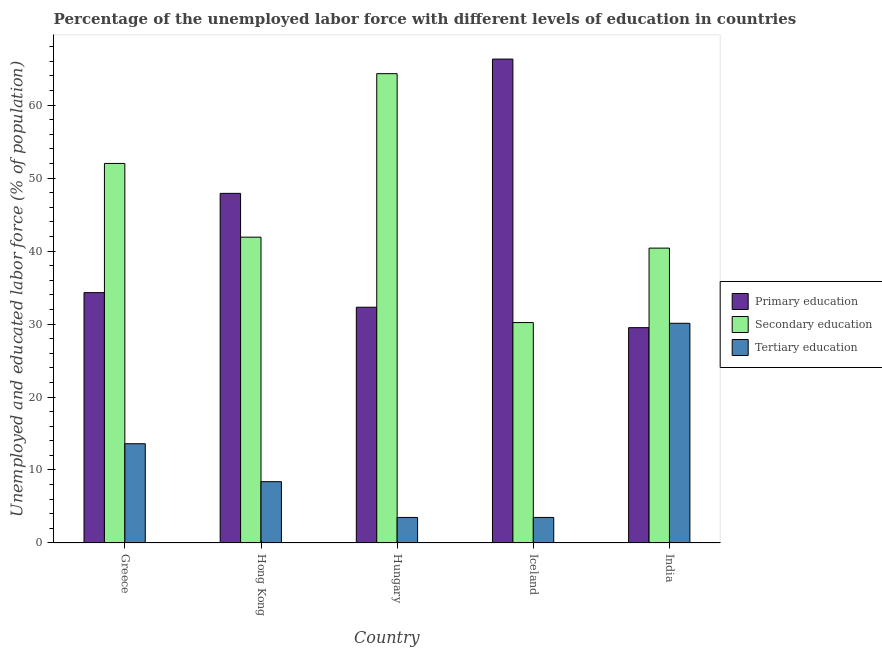How many bars are there on the 1st tick from the right?
Your answer should be compact. 3. What is the label of the 2nd group of bars from the left?
Provide a short and direct response. Hong Kong. What is the percentage of labor force who received primary education in India?
Provide a short and direct response. 29.5. Across all countries, what is the maximum percentage of labor force who received secondary education?
Your answer should be very brief. 64.3. Across all countries, what is the minimum percentage of labor force who received primary education?
Offer a very short reply. 29.5. In which country was the percentage of labor force who received tertiary education maximum?
Your answer should be compact. India. In which country was the percentage of labor force who received secondary education minimum?
Your answer should be very brief. Iceland. What is the total percentage of labor force who received primary education in the graph?
Make the answer very short. 210.3. What is the difference between the percentage of labor force who received tertiary education in Hong Kong and that in Hungary?
Ensure brevity in your answer.  4.9. What is the difference between the percentage of labor force who received secondary education in Iceland and the percentage of labor force who received primary education in India?
Keep it short and to the point. 0.7. What is the average percentage of labor force who received secondary education per country?
Provide a short and direct response. 45.76. What is the difference between the percentage of labor force who received secondary education and percentage of labor force who received primary education in India?
Your answer should be compact. 10.9. In how many countries, is the percentage of labor force who received tertiary education greater than 10 %?
Ensure brevity in your answer.  2. What is the ratio of the percentage of labor force who received secondary education in Greece to that in India?
Your answer should be very brief. 1.29. What is the difference between the highest and the second highest percentage of labor force who received secondary education?
Ensure brevity in your answer.  12.3. What is the difference between the highest and the lowest percentage of labor force who received secondary education?
Offer a very short reply. 34.1. Is the sum of the percentage of labor force who received secondary education in Hungary and Iceland greater than the maximum percentage of labor force who received tertiary education across all countries?
Your response must be concise. Yes. What does the 3rd bar from the left in Hungary represents?
Your answer should be compact. Tertiary education. What does the 2nd bar from the right in Hungary represents?
Ensure brevity in your answer.  Secondary education. What is the difference between two consecutive major ticks on the Y-axis?
Provide a short and direct response. 10. Does the graph contain any zero values?
Your response must be concise. No. Where does the legend appear in the graph?
Provide a succinct answer. Center right. What is the title of the graph?
Ensure brevity in your answer.  Percentage of the unemployed labor force with different levels of education in countries. Does "Male employers" appear as one of the legend labels in the graph?
Make the answer very short. No. What is the label or title of the Y-axis?
Give a very brief answer. Unemployed and educated labor force (% of population). What is the Unemployed and educated labor force (% of population) of Primary education in Greece?
Your response must be concise. 34.3. What is the Unemployed and educated labor force (% of population) in Secondary education in Greece?
Your answer should be compact. 52. What is the Unemployed and educated labor force (% of population) in Tertiary education in Greece?
Make the answer very short. 13.6. What is the Unemployed and educated labor force (% of population) of Primary education in Hong Kong?
Your answer should be very brief. 47.9. What is the Unemployed and educated labor force (% of population) in Secondary education in Hong Kong?
Give a very brief answer. 41.9. What is the Unemployed and educated labor force (% of population) of Tertiary education in Hong Kong?
Your response must be concise. 8.4. What is the Unemployed and educated labor force (% of population) in Primary education in Hungary?
Make the answer very short. 32.3. What is the Unemployed and educated labor force (% of population) in Secondary education in Hungary?
Your answer should be very brief. 64.3. What is the Unemployed and educated labor force (% of population) of Tertiary education in Hungary?
Make the answer very short. 3.5. What is the Unemployed and educated labor force (% of population) in Primary education in Iceland?
Offer a terse response. 66.3. What is the Unemployed and educated labor force (% of population) in Secondary education in Iceland?
Your answer should be compact. 30.2. What is the Unemployed and educated labor force (% of population) in Primary education in India?
Offer a terse response. 29.5. What is the Unemployed and educated labor force (% of population) in Secondary education in India?
Your answer should be very brief. 40.4. What is the Unemployed and educated labor force (% of population) in Tertiary education in India?
Your answer should be compact. 30.1. Across all countries, what is the maximum Unemployed and educated labor force (% of population) of Primary education?
Offer a very short reply. 66.3. Across all countries, what is the maximum Unemployed and educated labor force (% of population) in Secondary education?
Offer a very short reply. 64.3. Across all countries, what is the maximum Unemployed and educated labor force (% of population) of Tertiary education?
Give a very brief answer. 30.1. Across all countries, what is the minimum Unemployed and educated labor force (% of population) of Primary education?
Keep it short and to the point. 29.5. Across all countries, what is the minimum Unemployed and educated labor force (% of population) in Secondary education?
Keep it short and to the point. 30.2. Across all countries, what is the minimum Unemployed and educated labor force (% of population) in Tertiary education?
Your answer should be compact. 3.5. What is the total Unemployed and educated labor force (% of population) of Primary education in the graph?
Ensure brevity in your answer.  210.3. What is the total Unemployed and educated labor force (% of population) of Secondary education in the graph?
Ensure brevity in your answer.  228.8. What is the total Unemployed and educated labor force (% of population) of Tertiary education in the graph?
Your answer should be very brief. 59.1. What is the difference between the Unemployed and educated labor force (% of population) in Primary education in Greece and that in Hong Kong?
Make the answer very short. -13.6. What is the difference between the Unemployed and educated labor force (% of population) in Tertiary education in Greece and that in Hong Kong?
Your response must be concise. 5.2. What is the difference between the Unemployed and educated labor force (% of population) in Primary education in Greece and that in Hungary?
Provide a short and direct response. 2. What is the difference between the Unemployed and educated labor force (% of population) of Primary education in Greece and that in Iceland?
Provide a succinct answer. -32. What is the difference between the Unemployed and educated labor force (% of population) in Secondary education in Greece and that in Iceland?
Ensure brevity in your answer.  21.8. What is the difference between the Unemployed and educated labor force (% of population) of Tertiary education in Greece and that in Iceland?
Keep it short and to the point. 10.1. What is the difference between the Unemployed and educated labor force (% of population) of Primary education in Greece and that in India?
Offer a very short reply. 4.8. What is the difference between the Unemployed and educated labor force (% of population) of Secondary education in Greece and that in India?
Provide a short and direct response. 11.6. What is the difference between the Unemployed and educated labor force (% of population) of Tertiary education in Greece and that in India?
Provide a short and direct response. -16.5. What is the difference between the Unemployed and educated labor force (% of population) in Secondary education in Hong Kong and that in Hungary?
Your answer should be compact. -22.4. What is the difference between the Unemployed and educated labor force (% of population) of Primary education in Hong Kong and that in Iceland?
Keep it short and to the point. -18.4. What is the difference between the Unemployed and educated labor force (% of population) of Secondary education in Hong Kong and that in India?
Your answer should be compact. 1.5. What is the difference between the Unemployed and educated labor force (% of population) of Tertiary education in Hong Kong and that in India?
Make the answer very short. -21.7. What is the difference between the Unemployed and educated labor force (% of population) of Primary education in Hungary and that in Iceland?
Provide a short and direct response. -34. What is the difference between the Unemployed and educated labor force (% of population) of Secondary education in Hungary and that in Iceland?
Offer a terse response. 34.1. What is the difference between the Unemployed and educated labor force (% of population) in Tertiary education in Hungary and that in Iceland?
Keep it short and to the point. 0. What is the difference between the Unemployed and educated labor force (% of population) of Secondary education in Hungary and that in India?
Ensure brevity in your answer.  23.9. What is the difference between the Unemployed and educated labor force (% of population) of Tertiary education in Hungary and that in India?
Your response must be concise. -26.6. What is the difference between the Unemployed and educated labor force (% of population) in Primary education in Iceland and that in India?
Your response must be concise. 36.8. What is the difference between the Unemployed and educated labor force (% of population) in Secondary education in Iceland and that in India?
Make the answer very short. -10.2. What is the difference between the Unemployed and educated labor force (% of population) in Tertiary education in Iceland and that in India?
Provide a succinct answer. -26.6. What is the difference between the Unemployed and educated labor force (% of population) in Primary education in Greece and the Unemployed and educated labor force (% of population) in Tertiary education in Hong Kong?
Give a very brief answer. 25.9. What is the difference between the Unemployed and educated labor force (% of population) in Secondary education in Greece and the Unemployed and educated labor force (% of population) in Tertiary education in Hong Kong?
Provide a short and direct response. 43.6. What is the difference between the Unemployed and educated labor force (% of population) of Primary education in Greece and the Unemployed and educated labor force (% of population) of Tertiary education in Hungary?
Give a very brief answer. 30.8. What is the difference between the Unemployed and educated labor force (% of population) in Secondary education in Greece and the Unemployed and educated labor force (% of population) in Tertiary education in Hungary?
Make the answer very short. 48.5. What is the difference between the Unemployed and educated labor force (% of population) of Primary education in Greece and the Unemployed and educated labor force (% of population) of Tertiary education in Iceland?
Offer a very short reply. 30.8. What is the difference between the Unemployed and educated labor force (% of population) in Secondary education in Greece and the Unemployed and educated labor force (% of population) in Tertiary education in Iceland?
Your answer should be very brief. 48.5. What is the difference between the Unemployed and educated labor force (% of population) of Primary education in Greece and the Unemployed and educated labor force (% of population) of Secondary education in India?
Your response must be concise. -6.1. What is the difference between the Unemployed and educated labor force (% of population) of Primary education in Greece and the Unemployed and educated labor force (% of population) of Tertiary education in India?
Give a very brief answer. 4.2. What is the difference between the Unemployed and educated labor force (% of population) of Secondary education in Greece and the Unemployed and educated labor force (% of population) of Tertiary education in India?
Your answer should be very brief. 21.9. What is the difference between the Unemployed and educated labor force (% of population) in Primary education in Hong Kong and the Unemployed and educated labor force (% of population) in Secondary education in Hungary?
Your response must be concise. -16.4. What is the difference between the Unemployed and educated labor force (% of population) in Primary education in Hong Kong and the Unemployed and educated labor force (% of population) in Tertiary education in Hungary?
Your response must be concise. 44.4. What is the difference between the Unemployed and educated labor force (% of population) of Secondary education in Hong Kong and the Unemployed and educated labor force (% of population) of Tertiary education in Hungary?
Ensure brevity in your answer.  38.4. What is the difference between the Unemployed and educated labor force (% of population) of Primary education in Hong Kong and the Unemployed and educated labor force (% of population) of Tertiary education in Iceland?
Provide a short and direct response. 44.4. What is the difference between the Unemployed and educated labor force (% of population) in Secondary education in Hong Kong and the Unemployed and educated labor force (% of population) in Tertiary education in Iceland?
Keep it short and to the point. 38.4. What is the difference between the Unemployed and educated labor force (% of population) of Primary education in Hong Kong and the Unemployed and educated labor force (% of population) of Secondary education in India?
Keep it short and to the point. 7.5. What is the difference between the Unemployed and educated labor force (% of population) in Primary education in Hong Kong and the Unemployed and educated labor force (% of population) in Tertiary education in India?
Ensure brevity in your answer.  17.8. What is the difference between the Unemployed and educated labor force (% of population) in Primary education in Hungary and the Unemployed and educated labor force (% of population) in Secondary education in Iceland?
Keep it short and to the point. 2.1. What is the difference between the Unemployed and educated labor force (% of population) in Primary education in Hungary and the Unemployed and educated labor force (% of population) in Tertiary education in Iceland?
Give a very brief answer. 28.8. What is the difference between the Unemployed and educated labor force (% of population) in Secondary education in Hungary and the Unemployed and educated labor force (% of population) in Tertiary education in Iceland?
Offer a terse response. 60.8. What is the difference between the Unemployed and educated labor force (% of population) in Primary education in Hungary and the Unemployed and educated labor force (% of population) in Secondary education in India?
Make the answer very short. -8.1. What is the difference between the Unemployed and educated labor force (% of population) of Primary education in Hungary and the Unemployed and educated labor force (% of population) of Tertiary education in India?
Provide a succinct answer. 2.2. What is the difference between the Unemployed and educated labor force (% of population) in Secondary education in Hungary and the Unemployed and educated labor force (% of population) in Tertiary education in India?
Your response must be concise. 34.2. What is the difference between the Unemployed and educated labor force (% of population) of Primary education in Iceland and the Unemployed and educated labor force (% of population) of Secondary education in India?
Provide a short and direct response. 25.9. What is the difference between the Unemployed and educated labor force (% of population) in Primary education in Iceland and the Unemployed and educated labor force (% of population) in Tertiary education in India?
Your response must be concise. 36.2. What is the average Unemployed and educated labor force (% of population) in Primary education per country?
Your answer should be compact. 42.06. What is the average Unemployed and educated labor force (% of population) in Secondary education per country?
Your answer should be very brief. 45.76. What is the average Unemployed and educated labor force (% of population) in Tertiary education per country?
Your response must be concise. 11.82. What is the difference between the Unemployed and educated labor force (% of population) in Primary education and Unemployed and educated labor force (% of population) in Secondary education in Greece?
Offer a terse response. -17.7. What is the difference between the Unemployed and educated labor force (% of population) of Primary education and Unemployed and educated labor force (% of population) of Tertiary education in Greece?
Offer a very short reply. 20.7. What is the difference between the Unemployed and educated labor force (% of population) in Secondary education and Unemployed and educated labor force (% of population) in Tertiary education in Greece?
Your answer should be compact. 38.4. What is the difference between the Unemployed and educated labor force (% of population) of Primary education and Unemployed and educated labor force (% of population) of Secondary education in Hong Kong?
Offer a very short reply. 6. What is the difference between the Unemployed and educated labor force (% of population) of Primary education and Unemployed and educated labor force (% of population) of Tertiary education in Hong Kong?
Your answer should be very brief. 39.5. What is the difference between the Unemployed and educated labor force (% of population) in Secondary education and Unemployed and educated labor force (% of population) in Tertiary education in Hong Kong?
Provide a succinct answer. 33.5. What is the difference between the Unemployed and educated labor force (% of population) in Primary education and Unemployed and educated labor force (% of population) in Secondary education in Hungary?
Provide a short and direct response. -32. What is the difference between the Unemployed and educated labor force (% of population) in Primary education and Unemployed and educated labor force (% of population) in Tertiary education in Hungary?
Ensure brevity in your answer.  28.8. What is the difference between the Unemployed and educated labor force (% of population) in Secondary education and Unemployed and educated labor force (% of population) in Tertiary education in Hungary?
Offer a terse response. 60.8. What is the difference between the Unemployed and educated labor force (% of population) in Primary education and Unemployed and educated labor force (% of population) in Secondary education in Iceland?
Your answer should be compact. 36.1. What is the difference between the Unemployed and educated labor force (% of population) of Primary education and Unemployed and educated labor force (% of population) of Tertiary education in Iceland?
Your answer should be very brief. 62.8. What is the difference between the Unemployed and educated labor force (% of population) of Secondary education and Unemployed and educated labor force (% of population) of Tertiary education in Iceland?
Provide a succinct answer. 26.7. What is the difference between the Unemployed and educated labor force (% of population) of Primary education and Unemployed and educated labor force (% of population) of Secondary education in India?
Keep it short and to the point. -10.9. What is the difference between the Unemployed and educated labor force (% of population) in Primary education and Unemployed and educated labor force (% of population) in Tertiary education in India?
Make the answer very short. -0.6. What is the ratio of the Unemployed and educated labor force (% of population) of Primary education in Greece to that in Hong Kong?
Provide a short and direct response. 0.72. What is the ratio of the Unemployed and educated labor force (% of population) in Secondary education in Greece to that in Hong Kong?
Offer a terse response. 1.24. What is the ratio of the Unemployed and educated labor force (% of population) of Tertiary education in Greece to that in Hong Kong?
Give a very brief answer. 1.62. What is the ratio of the Unemployed and educated labor force (% of population) of Primary education in Greece to that in Hungary?
Make the answer very short. 1.06. What is the ratio of the Unemployed and educated labor force (% of population) of Secondary education in Greece to that in Hungary?
Your answer should be compact. 0.81. What is the ratio of the Unemployed and educated labor force (% of population) of Tertiary education in Greece to that in Hungary?
Your response must be concise. 3.89. What is the ratio of the Unemployed and educated labor force (% of population) in Primary education in Greece to that in Iceland?
Give a very brief answer. 0.52. What is the ratio of the Unemployed and educated labor force (% of population) of Secondary education in Greece to that in Iceland?
Make the answer very short. 1.72. What is the ratio of the Unemployed and educated labor force (% of population) in Tertiary education in Greece to that in Iceland?
Make the answer very short. 3.89. What is the ratio of the Unemployed and educated labor force (% of population) of Primary education in Greece to that in India?
Offer a terse response. 1.16. What is the ratio of the Unemployed and educated labor force (% of population) in Secondary education in Greece to that in India?
Your response must be concise. 1.29. What is the ratio of the Unemployed and educated labor force (% of population) in Tertiary education in Greece to that in India?
Give a very brief answer. 0.45. What is the ratio of the Unemployed and educated labor force (% of population) in Primary education in Hong Kong to that in Hungary?
Provide a succinct answer. 1.48. What is the ratio of the Unemployed and educated labor force (% of population) in Secondary education in Hong Kong to that in Hungary?
Ensure brevity in your answer.  0.65. What is the ratio of the Unemployed and educated labor force (% of population) of Tertiary education in Hong Kong to that in Hungary?
Ensure brevity in your answer.  2.4. What is the ratio of the Unemployed and educated labor force (% of population) in Primary education in Hong Kong to that in Iceland?
Offer a terse response. 0.72. What is the ratio of the Unemployed and educated labor force (% of population) in Secondary education in Hong Kong to that in Iceland?
Provide a short and direct response. 1.39. What is the ratio of the Unemployed and educated labor force (% of population) in Tertiary education in Hong Kong to that in Iceland?
Your answer should be compact. 2.4. What is the ratio of the Unemployed and educated labor force (% of population) in Primary education in Hong Kong to that in India?
Your response must be concise. 1.62. What is the ratio of the Unemployed and educated labor force (% of population) in Secondary education in Hong Kong to that in India?
Your response must be concise. 1.04. What is the ratio of the Unemployed and educated labor force (% of population) in Tertiary education in Hong Kong to that in India?
Offer a terse response. 0.28. What is the ratio of the Unemployed and educated labor force (% of population) of Primary education in Hungary to that in Iceland?
Ensure brevity in your answer.  0.49. What is the ratio of the Unemployed and educated labor force (% of population) in Secondary education in Hungary to that in Iceland?
Make the answer very short. 2.13. What is the ratio of the Unemployed and educated labor force (% of population) in Primary education in Hungary to that in India?
Ensure brevity in your answer.  1.09. What is the ratio of the Unemployed and educated labor force (% of population) of Secondary education in Hungary to that in India?
Offer a very short reply. 1.59. What is the ratio of the Unemployed and educated labor force (% of population) of Tertiary education in Hungary to that in India?
Provide a short and direct response. 0.12. What is the ratio of the Unemployed and educated labor force (% of population) in Primary education in Iceland to that in India?
Provide a short and direct response. 2.25. What is the ratio of the Unemployed and educated labor force (% of population) of Secondary education in Iceland to that in India?
Offer a terse response. 0.75. What is the ratio of the Unemployed and educated labor force (% of population) of Tertiary education in Iceland to that in India?
Provide a short and direct response. 0.12. What is the difference between the highest and the second highest Unemployed and educated labor force (% of population) in Primary education?
Keep it short and to the point. 18.4. What is the difference between the highest and the second highest Unemployed and educated labor force (% of population) of Secondary education?
Ensure brevity in your answer.  12.3. What is the difference between the highest and the lowest Unemployed and educated labor force (% of population) of Primary education?
Your response must be concise. 36.8. What is the difference between the highest and the lowest Unemployed and educated labor force (% of population) of Secondary education?
Give a very brief answer. 34.1. What is the difference between the highest and the lowest Unemployed and educated labor force (% of population) of Tertiary education?
Keep it short and to the point. 26.6. 